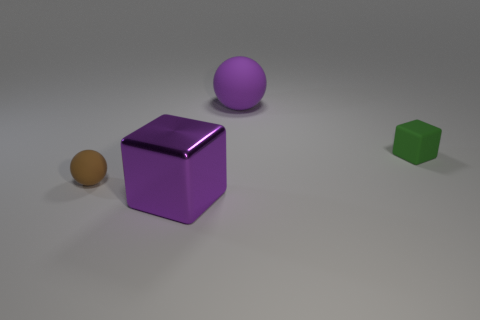How many balls are green things or tiny objects?
Keep it short and to the point. 1. What is the material of the other big thing that is the same color as the large metal object?
Your answer should be compact. Rubber. Is the number of big spheres that are behind the small brown sphere less than the number of tiny brown matte spheres that are behind the big purple rubber sphere?
Ensure brevity in your answer.  No. How many things are either purple things that are behind the tiny block or tiny rubber blocks?
Your answer should be very brief. 2. There is a small matte object left of the ball on the right side of the brown ball; what shape is it?
Your response must be concise. Sphere. Are there any other metal things of the same size as the purple metallic thing?
Make the answer very short. No. Is the number of green rubber balls greater than the number of small brown rubber objects?
Your response must be concise. No. There is a matte sphere that is behind the brown object; is its size the same as the purple thing that is in front of the small brown rubber object?
Your answer should be compact. Yes. What number of objects are both on the left side of the large purple sphere and right of the small ball?
Provide a succinct answer. 1. There is another big thing that is the same shape as the green object; what is its color?
Offer a terse response. Purple. 